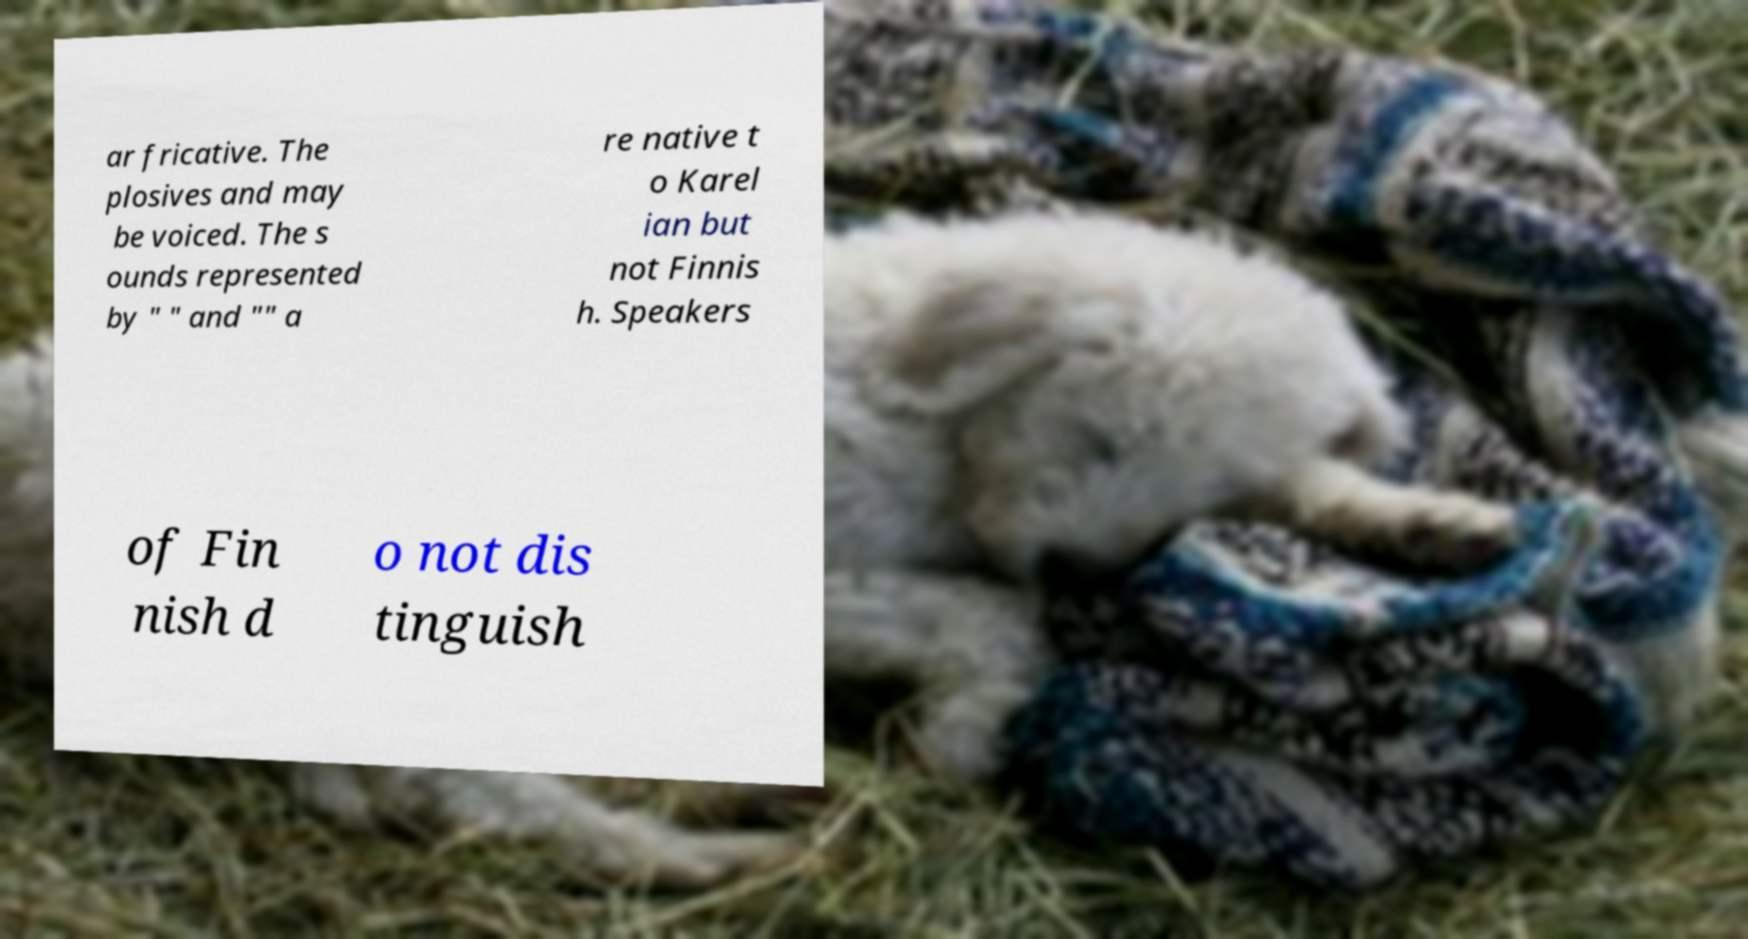For documentation purposes, I need the text within this image transcribed. Could you provide that? ar fricative. The plosives and may be voiced. The s ounds represented by " " and "" a re native t o Karel ian but not Finnis h. Speakers of Fin nish d o not dis tinguish 